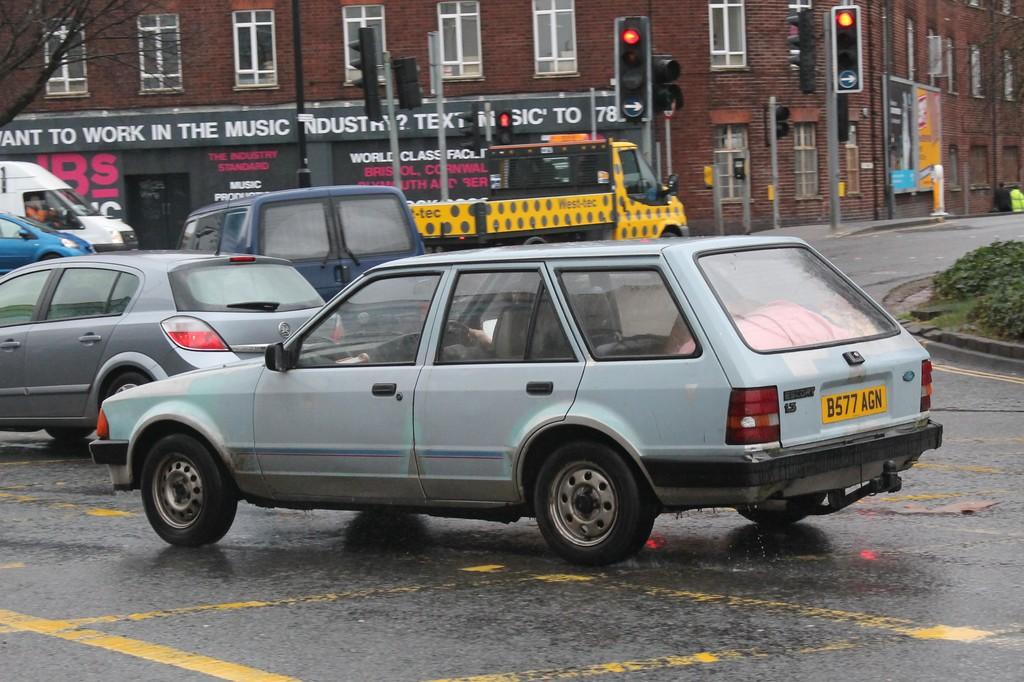<image>
Render a clear and concise summary of the photo. A grey car is at a red light and its license plate says B577 AGN. 